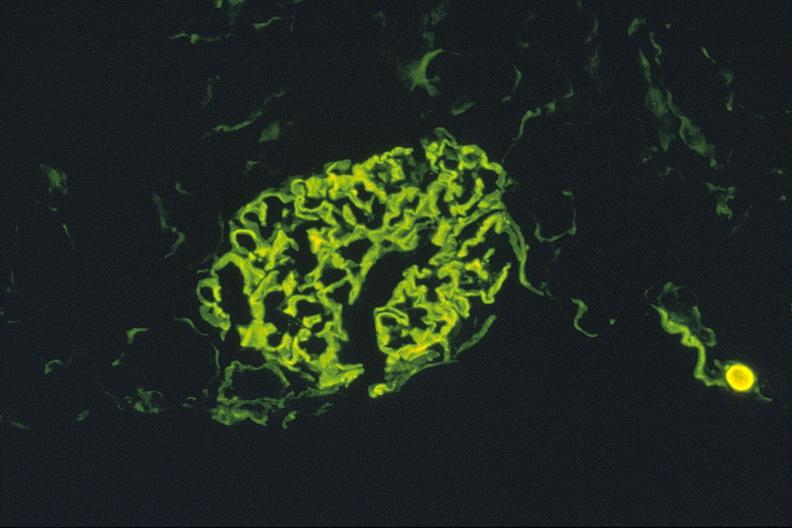what is present?
Answer the question using a single word or phrase. Urinary 